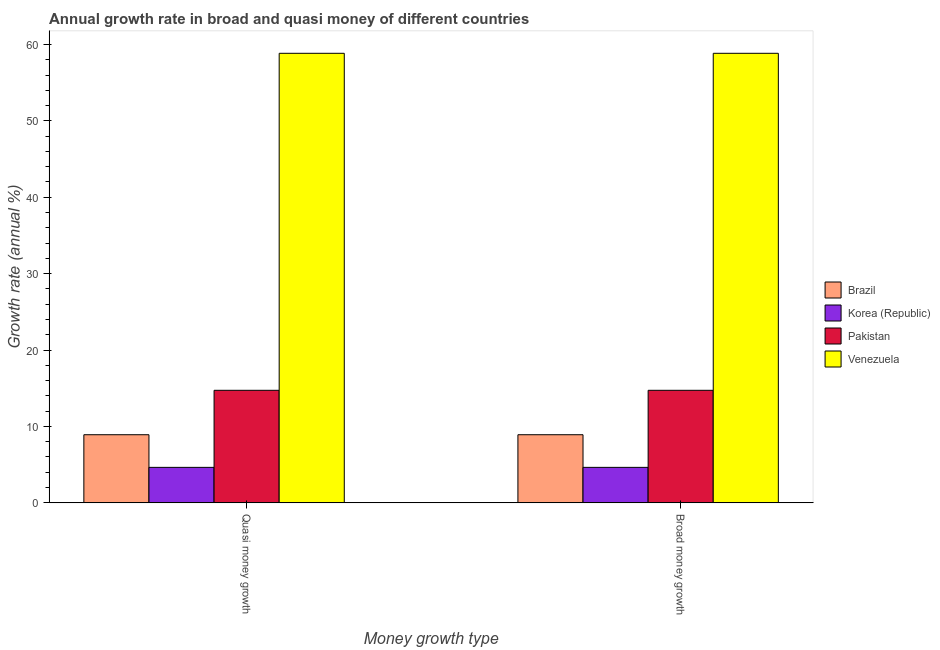How many different coloured bars are there?
Your answer should be very brief. 4. How many bars are there on the 2nd tick from the left?
Provide a short and direct response. 4. What is the label of the 1st group of bars from the left?
Your answer should be very brief. Quasi money growth. What is the annual growth rate in broad money in Venezuela?
Give a very brief answer. 58.84. Across all countries, what is the maximum annual growth rate in quasi money?
Make the answer very short. 58.84. Across all countries, what is the minimum annual growth rate in broad money?
Make the answer very short. 4.64. In which country was the annual growth rate in broad money maximum?
Provide a succinct answer. Venezuela. In which country was the annual growth rate in quasi money minimum?
Provide a short and direct response. Korea (Republic). What is the total annual growth rate in quasi money in the graph?
Keep it short and to the point. 87.12. What is the difference between the annual growth rate in quasi money in Pakistan and that in Brazil?
Your answer should be very brief. 5.82. What is the difference between the annual growth rate in broad money in Venezuela and the annual growth rate in quasi money in Brazil?
Provide a short and direct response. 49.93. What is the average annual growth rate in quasi money per country?
Offer a terse response. 21.78. What is the difference between the annual growth rate in broad money and annual growth rate in quasi money in Korea (Republic)?
Keep it short and to the point. 0. What is the ratio of the annual growth rate in broad money in Brazil to that in Venezuela?
Make the answer very short. 0.15. In how many countries, is the annual growth rate in quasi money greater than the average annual growth rate in quasi money taken over all countries?
Your answer should be very brief. 1. How many countries are there in the graph?
Give a very brief answer. 4. What is the difference between two consecutive major ticks on the Y-axis?
Your response must be concise. 10. Does the graph contain grids?
Provide a short and direct response. No. Where does the legend appear in the graph?
Make the answer very short. Center right. How are the legend labels stacked?
Provide a succinct answer. Vertical. What is the title of the graph?
Your answer should be very brief. Annual growth rate in broad and quasi money of different countries. Does "Pacific island small states" appear as one of the legend labels in the graph?
Provide a succinct answer. No. What is the label or title of the X-axis?
Ensure brevity in your answer.  Money growth type. What is the label or title of the Y-axis?
Offer a very short reply. Growth rate (annual %). What is the Growth rate (annual %) of Brazil in Quasi money growth?
Make the answer very short. 8.91. What is the Growth rate (annual %) in Korea (Republic) in Quasi money growth?
Offer a very short reply. 4.64. What is the Growth rate (annual %) of Pakistan in Quasi money growth?
Provide a succinct answer. 14.73. What is the Growth rate (annual %) in Venezuela in Quasi money growth?
Ensure brevity in your answer.  58.84. What is the Growth rate (annual %) in Brazil in Broad money growth?
Keep it short and to the point. 8.91. What is the Growth rate (annual %) in Korea (Republic) in Broad money growth?
Provide a succinct answer. 4.64. What is the Growth rate (annual %) of Pakistan in Broad money growth?
Offer a very short reply. 14.73. What is the Growth rate (annual %) of Venezuela in Broad money growth?
Provide a succinct answer. 58.84. Across all Money growth type, what is the maximum Growth rate (annual %) of Brazil?
Ensure brevity in your answer.  8.91. Across all Money growth type, what is the maximum Growth rate (annual %) in Korea (Republic)?
Provide a succinct answer. 4.64. Across all Money growth type, what is the maximum Growth rate (annual %) in Pakistan?
Give a very brief answer. 14.73. Across all Money growth type, what is the maximum Growth rate (annual %) in Venezuela?
Give a very brief answer. 58.84. Across all Money growth type, what is the minimum Growth rate (annual %) of Brazil?
Your answer should be compact. 8.91. Across all Money growth type, what is the minimum Growth rate (annual %) of Korea (Republic)?
Give a very brief answer. 4.64. Across all Money growth type, what is the minimum Growth rate (annual %) in Pakistan?
Your answer should be compact. 14.73. Across all Money growth type, what is the minimum Growth rate (annual %) of Venezuela?
Give a very brief answer. 58.84. What is the total Growth rate (annual %) in Brazil in the graph?
Ensure brevity in your answer.  17.82. What is the total Growth rate (annual %) of Korea (Republic) in the graph?
Keep it short and to the point. 9.28. What is the total Growth rate (annual %) of Pakistan in the graph?
Keep it short and to the point. 29.46. What is the total Growth rate (annual %) in Venezuela in the graph?
Make the answer very short. 117.69. What is the difference between the Growth rate (annual %) in Korea (Republic) in Quasi money growth and that in Broad money growth?
Your answer should be compact. 0. What is the difference between the Growth rate (annual %) in Pakistan in Quasi money growth and that in Broad money growth?
Your answer should be very brief. 0. What is the difference between the Growth rate (annual %) of Brazil in Quasi money growth and the Growth rate (annual %) of Korea (Republic) in Broad money growth?
Give a very brief answer. 4.27. What is the difference between the Growth rate (annual %) of Brazil in Quasi money growth and the Growth rate (annual %) of Pakistan in Broad money growth?
Keep it short and to the point. -5.82. What is the difference between the Growth rate (annual %) in Brazil in Quasi money growth and the Growth rate (annual %) in Venezuela in Broad money growth?
Keep it short and to the point. -49.93. What is the difference between the Growth rate (annual %) in Korea (Republic) in Quasi money growth and the Growth rate (annual %) in Pakistan in Broad money growth?
Your response must be concise. -10.09. What is the difference between the Growth rate (annual %) of Korea (Republic) in Quasi money growth and the Growth rate (annual %) of Venezuela in Broad money growth?
Offer a terse response. -54.2. What is the difference between the Growth rate (annual %) of Pakistan in Quasi money growth and the Growth rate (annual %) of Venezuela in Broad money growth?
Your response must be concise. -44.12. What is the average Growth rate (annual %) of Brazil per Money growth type?
Provide a short and direct response. 8.91. What is the average Growth rate (annual %) of Korea (Republic) per Money growth type?
Give a very brief answer. 4.64. What is the average Growth rate (annual %) of Pakistan per Money growth type?
Provide a succinct answer. 14.73. What is the average Growth rate (annual %) in Venezuela per Money growth type?
Your response must be concise. 58.84. What is the difference between the Growth rate (annual %) in Brazil and Growth rate (annual %) in Korea (Republic) in Quasi money growth?
Keep it short and to the point. 4.27. What is the difference between the Growth rate (annual %) in Brazil and Growth rate (annual %) in Pakistan in Quasi money growth?
Ensure brevity in your answer.  -5.82. What is the difference between the Growth rate (annual %) in Brazil and Growth rate (annual %) in Venezuela in Quasi money growth?
Your answer should be very brief. -49.93. What is the difference between the Growth rate (annual %) in Korea (Republic) and Growth rate (annual %) in Pakistan in Quasi money growth?
Your response must be concise. -10.09. What is the difference between the Growth rate (annual %) of Korea (Republic) and Growth rate (annual %) of Venezuela in Quasi money growth?
Provide a short and direct response. -54.2. What is the difference between the Growth rate (annual %) of Pakistan and Growth rate (annual %) of Venezuela in Quasi money growth?
Provide a short and direct response. -44.12. What is the difference between the Growth rate (annual %) in Brazil and Growth rate (annual %) in Korea (Republic) in Broad money growth?
Keep it short and to the point. 4.27. What is the difference between the Growth rate (annual %) of Brazil and Growth rate (annual %) of Pakistan in Broad money growth?
Your answer should be compact. -5.82. What is the difference between the Growth rate (annual %) of Brazil and Growth rate (annual %) of Venezuela in Broad money growth?
Your response must be concise. -49.93. What is the difference between the Growth rate (annual %) in Korea (Republic) and Growth rate (annual %) in Pakistan in Broad money growth?
Your answer should be compact. -10.09. What is the difference between the Growth rate (annual %) of Korea (Republic) and Growth rate (annual %) of Venezuela in Broad money growth?
Give a very brief answer. -54.2. What is the difference between the Growth rate (annual %) in Pakistan and Growth rate (annual %) in Venezuela in Broad money growth?
Provide a short and direct response. -44.12. What is the ratio of the Growth rate (annual %) of Brazil in Quasi money growth to that in Broad money growth?
Provide a short and direct response. 1. What is the difference between the highest and the second highest Growth rate (annual %) in Brazil?
Offer a terse response. 0. What is the difference between the highest and the second highest Growth rate (annual %) in Korea (Republic)?
Your answer should be very brief. 0. What is the difference between the highest and the second highest Growth rate (annual %) of Pakistan?
Give a very brief answer. 0. What is the difference between the highest and the second highest Growth rate (annual %) of Venezuela?
Your response must be concise. 0. What is the difference between the highest and the lowest Growth rate (annual %) of Brazil?
Keep it short and to the point. 0. What is the difference between the highest and the lowest Growth rate (annual %) of Korea (Republic)?
Ensure brevity in your answer.  0. What is the difference between the highest and the lowest Growth rate (annual %) of Pakistan?
Make the answer very short. 0. What is the difference between the highest and the lowest Growth rate (annual %) in Venezuela?
Offer a terse response. 0. 